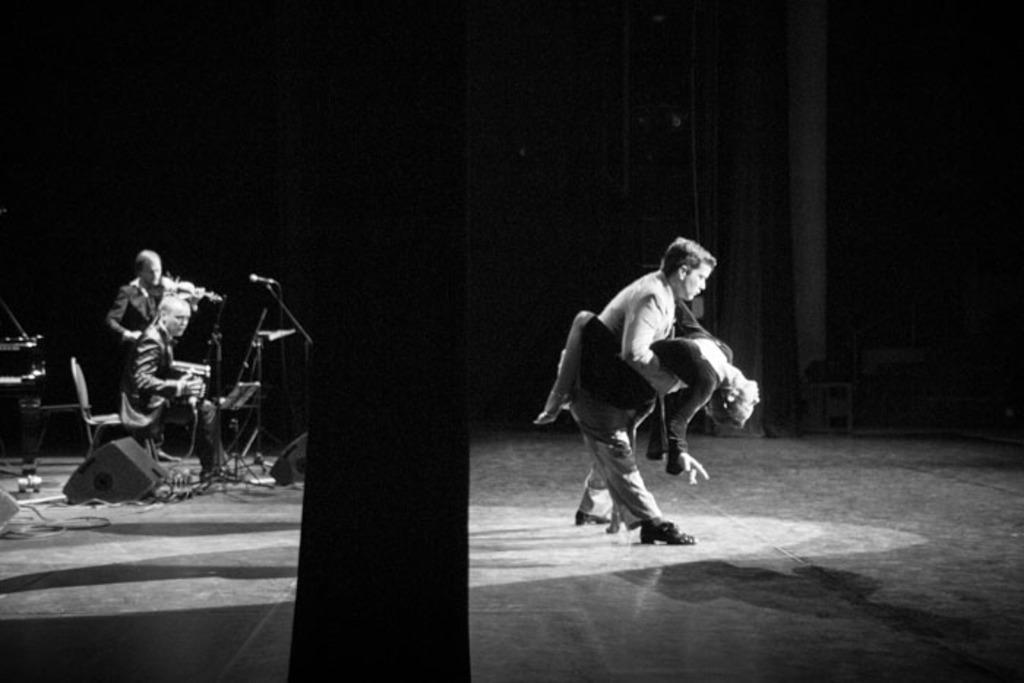What are the man and woman doing in the image? The man and woman are dancing in the image. What are the two men doing in the image? The two men are playing musical instruments in the image. What can be observed about the lighting in the image? The background of the image is dark. What type of flower is being used as a trick by the expert in the image? There is no flower or expert present in the image; it features a dancing couple and musicians. 